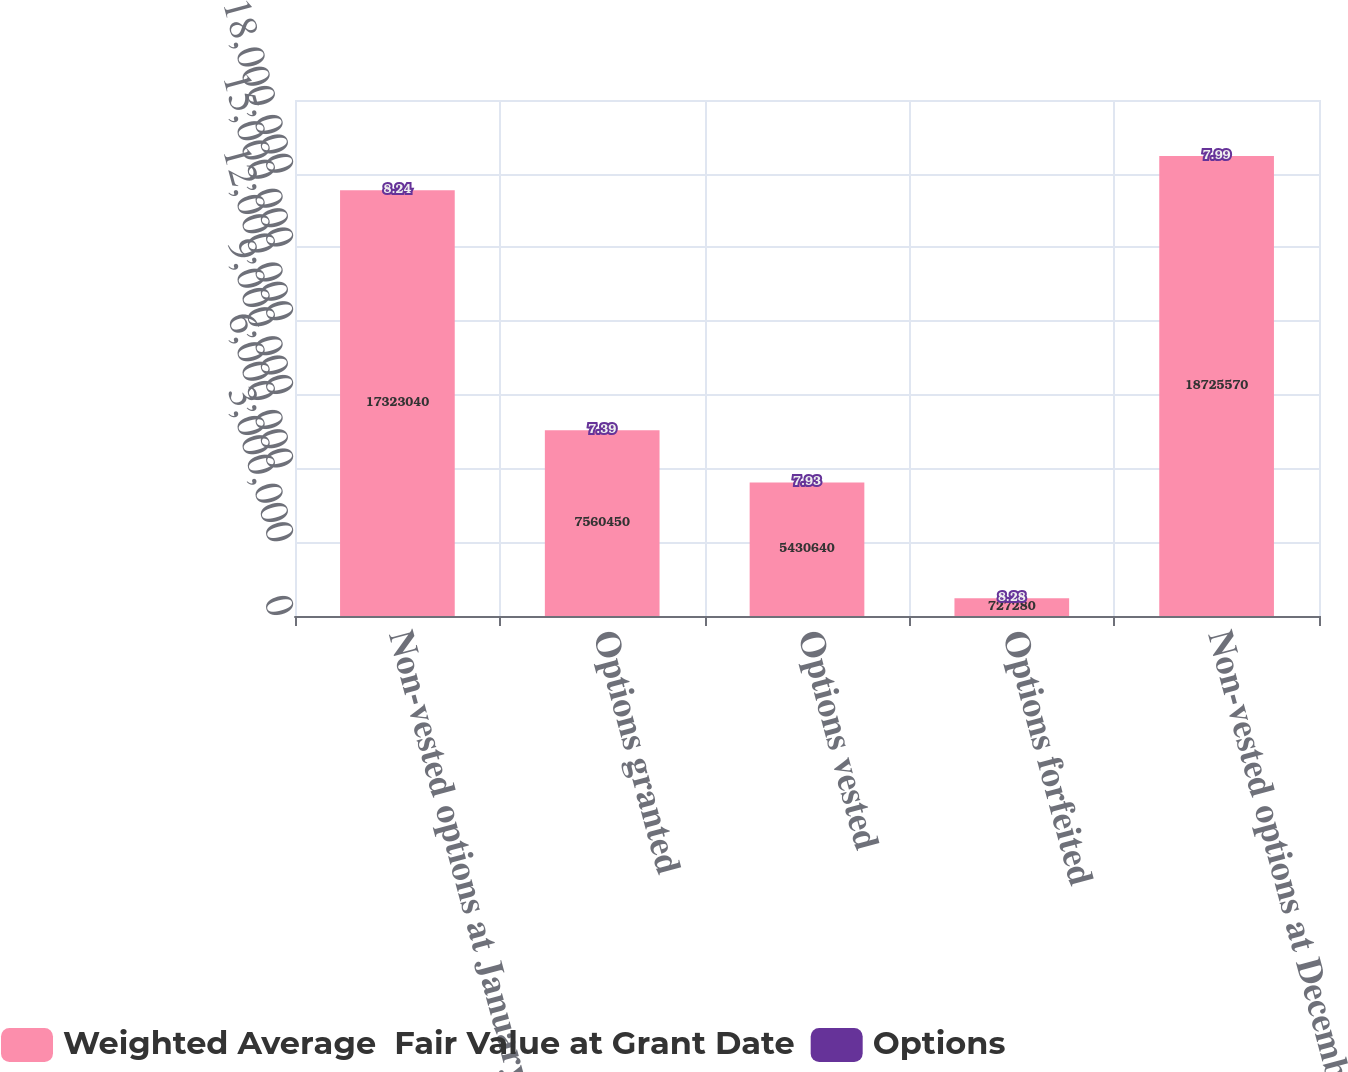Convert chart to OTSL. <chart><loc_0><loc_0><loc_500><loc_500><stacked_bar_chart><ecel><fcel>Non-vested options at January<fcel>Options granted<fcel>Options vested<fcel>Options forfeited<fcel>Non-vested options at December<nl><fcel>Weighted Average  Fair Value at Grant Date<fcel>1.7323e+07<fcel>7.56045e+06<fcel>5.43064e+06<fcel>727280<fcel>1.87256e+07<nl><fcel>Options<fcel>8.24<fcel>7.39<fcel>7.93<fcel>8.28<fcel>7.99<nl></chart> 